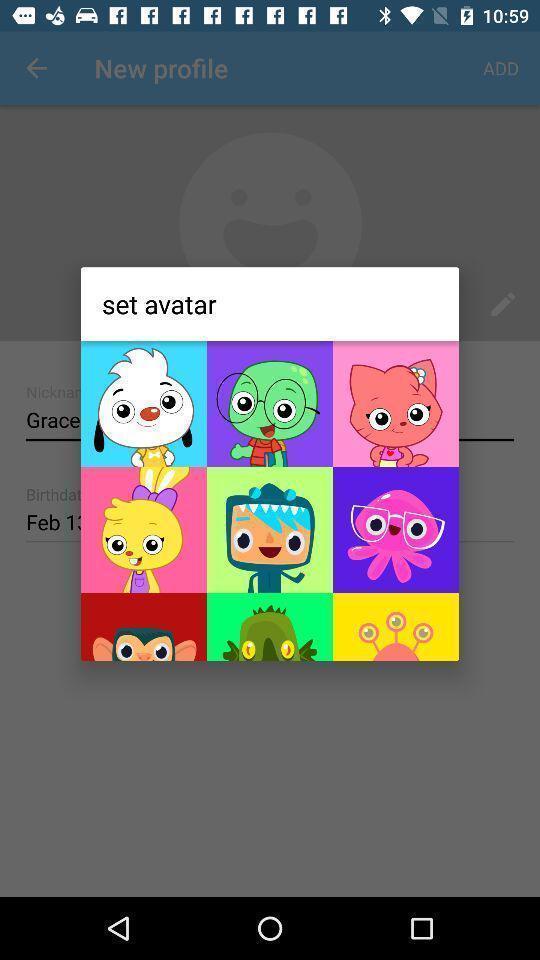Tell me what you see in this picture. Pop-up displaying multiple avatars. 